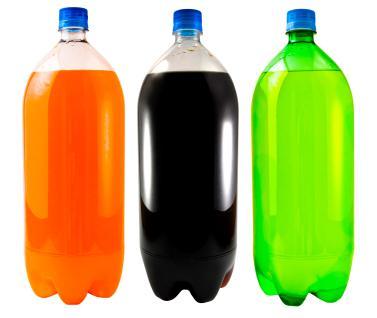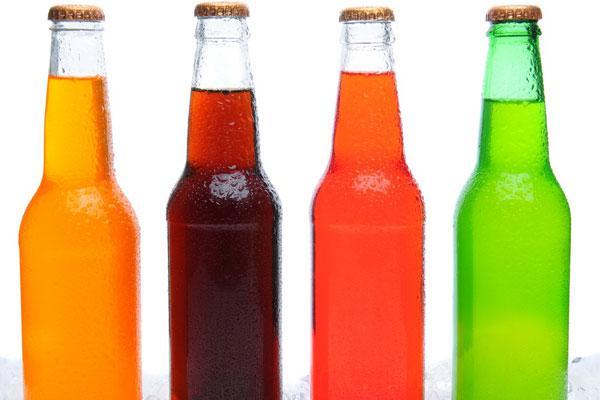The first image is the image on the left, the second image is the image on the right. For the images displayed, is the sentence "No image includes a label with printing on it, and one image contains a straight row of at least four bottles of different colored liquids." factually correct? Answer yes or no. Yes. The first image is the image on the left, the second image is the image on the right. Given the left and right images, does the statement "Three 2 liter soda bottles have no labels." hold true? Answer yes or no. Yes. 